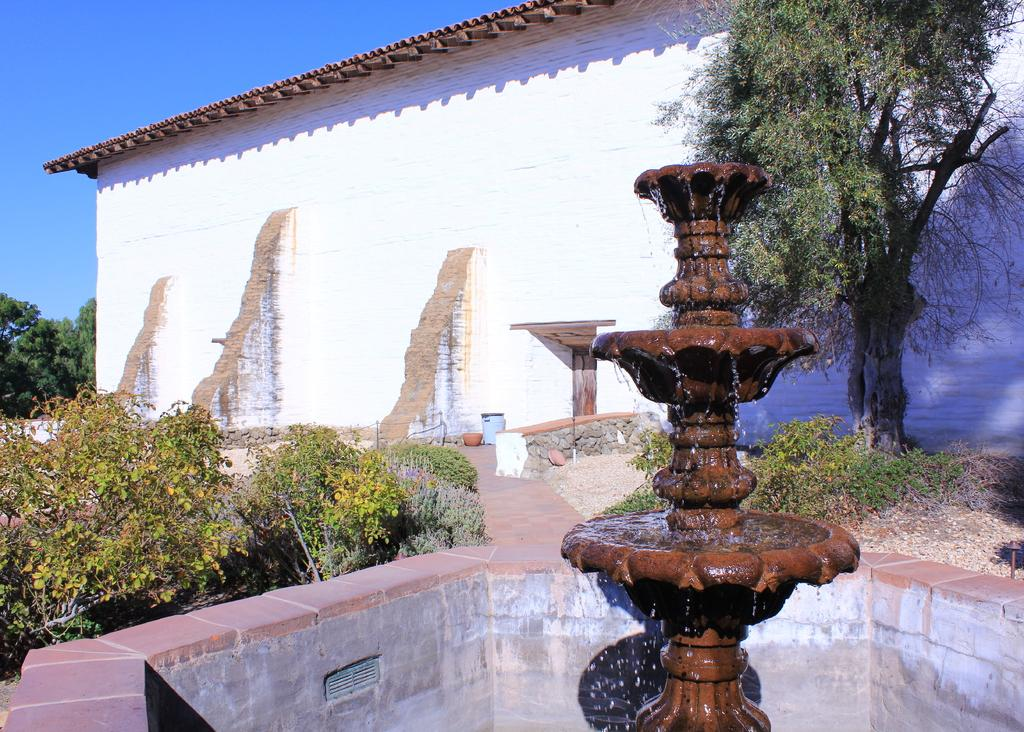What is the main feature in the image? There is a fountain with water in the image. What other celestial bodies are present near the fountain? There are planets beside the fountain. What can be seen in the image that people might walk on? There is a path in the image. What else is visible in the image besides the fountain and path? There are some objects in the image. What can be seen in the background of the image? There is a building, trees, and the sky visible in the background of the image. What type of coal is being used to fuel the fountain in the image? There is no coal present in the image, and the fountain is not fueled by coal. Can you see a robin perched on the fountain in the image? There is no robin present in the image. 